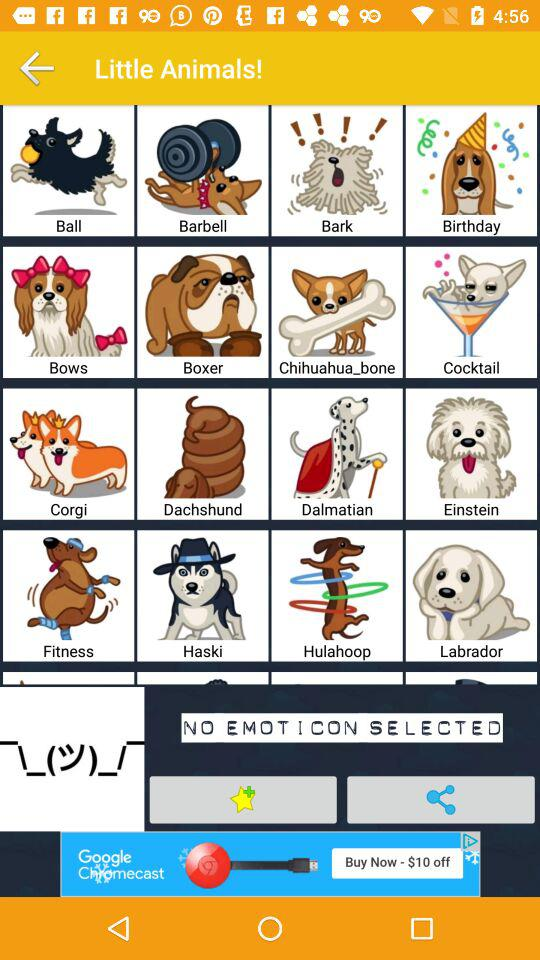What's the application name?
When the provided information is insufficient, respond with <no answer>. <no answer> 